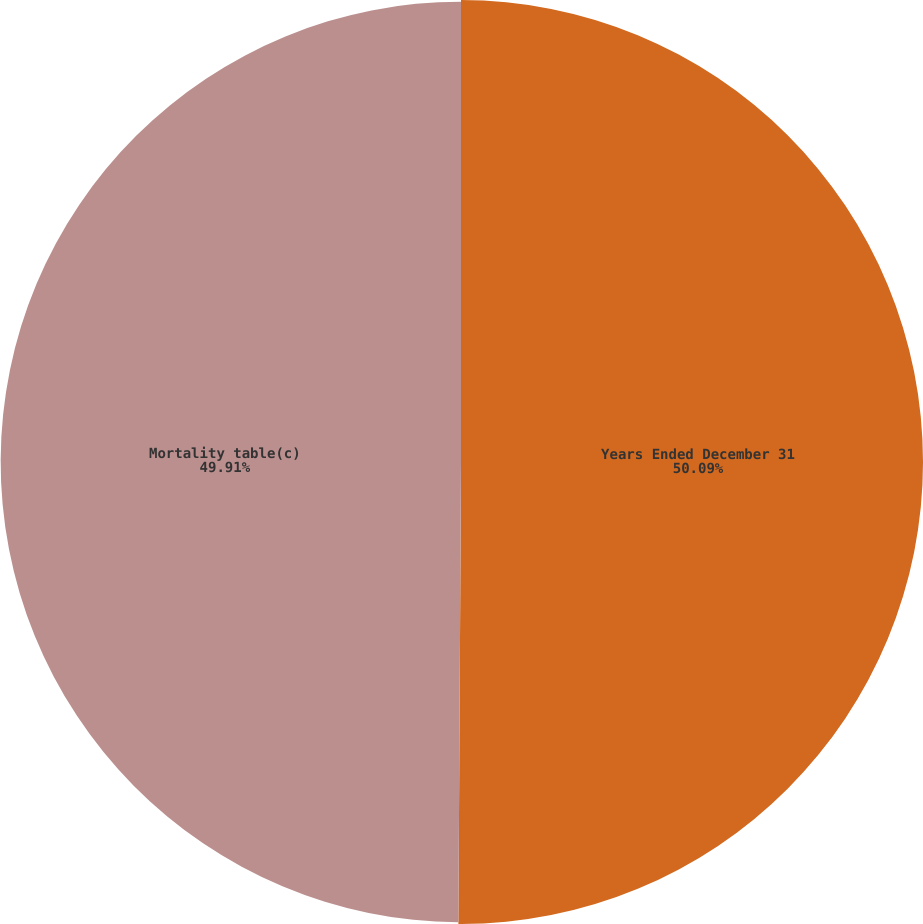Convert chart to OTSL. <chart><loc_0><loc_0><loc_500><loc_500><pie_chart><fcel>Years Ended December 31<fcel>Mortality table(c)<nl><fcel>50.09%<fcel>49.91%<nl></chart> 